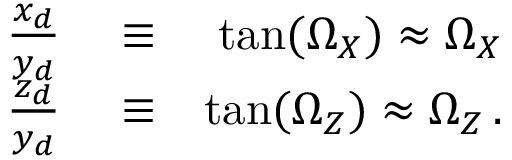Convert formula to latex. <formula><loc_0><loc_0><loc_500><loc_500>\begin{array} { r l r } { \frac { x _ { d } } { y _ { d } } } & \equiv } & { \tan ( \Omega _ { X } ) \approx \Omega _ { X } } \\ { \frac { z _ { d } } { y _ { d } } } & \equiv } & { \tan ( \Omega _ { Z } ) \approx \Omega _ { Z } \, . } \end{array}</formula> 